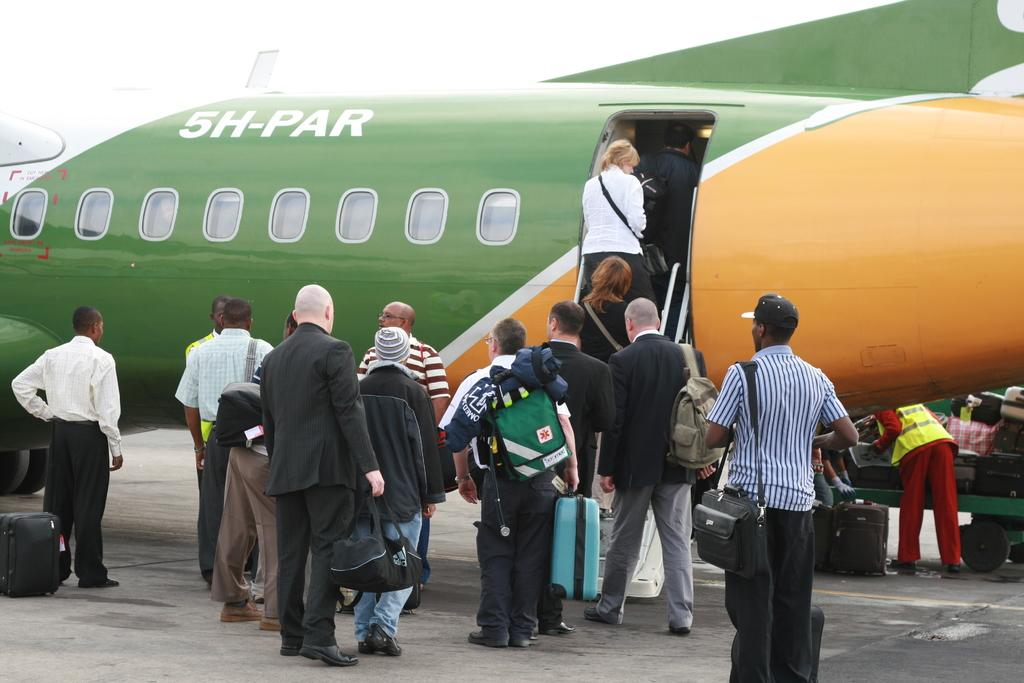<image>
Write a terse but informative summary of the picture. People are boarding on a commercial airplane with the name SH-PAR on it. 